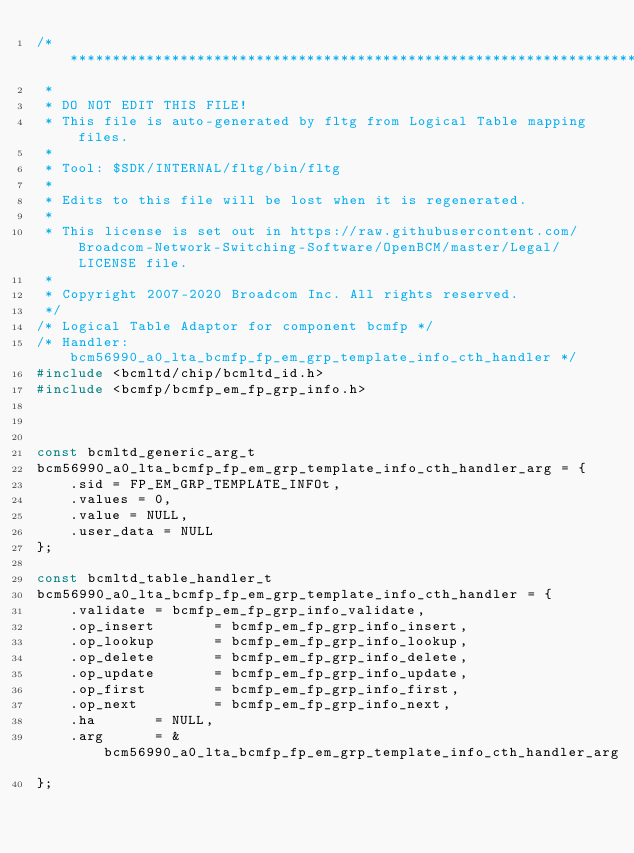Convert code to text. <code><loc_0><loc_0><loc_500><loc_500><_C_>/*******************************************************************************
 *
 * DO NOT EDIT THIS FILE!
 * This file is auto-generated by fltg from Logical Table mapping files.
 *
 * Tool: $SDK/INTERNAL/fltg/bin/fltg
 *
 * Edits to this file will be lost when it is regenerated.
 *
 * This license is set out in https://raw.githubusercontent.com/Broadcom-Network-Switching-Software/OpenBCM/master/Legal/LICENSE file.
 * 
 * Copyright 2007-2020 Broadcom Inc. All rights reserved.
 */
/* Logical Table Adaptor for component bcmfp */
/* Handler: bcm56990_a0_lta_bcmfp_fp_em_grp_template_info_cth_handler */
#include <bcmltd/chip/bcmltd_id.h>
#include <bcmfp/bcmfp_em_fp_grp_info.h>



const bcmltd_generic_arg_t
bcm56990_a0_lta_bcmfp_fp_em_grp_template_info_cth_handler_arg = {
    .sid = FP_EM_GRP_TEMPLATE_INFOt,
    .values = 0,
    .value = NULL,
    .user_data = NULL
};

const bcmltd_table_handler_t
bcm56990_a0_lta_bcmfp_fp_em_grp_template_info_cth_handler = {
    .validate = bcmfp_em_fp_grp_info_validate,
    .op_insert       = bcmfp_em_fp_grp_info_insert,
    .op_lookup       = bcmfp_em_fp_grp_info_lookup,
    .op_delete       = bcmfp_em_fp_grp_info_delete,
    .op_update       = bcmfp_em_fp_grp_info_update,
    .op_first        = bcmfp_em_fp_grp_info_first,
    .op_next         = bcmfp_em_fp_grp_info_next,
    .ha       = NULL,
    .arg      = &bcm56990_a0_lta_bcmfp_fp_em_grp_template_info_cth_handler_arg
};

</code> 